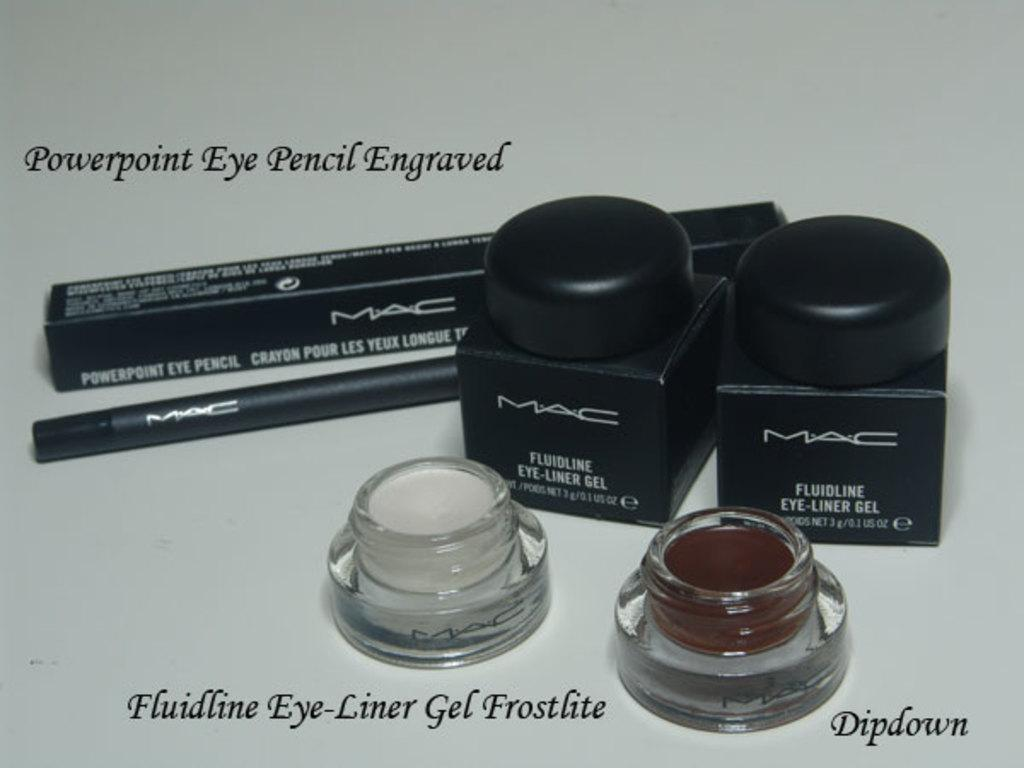Provide a one-sentence caption for the provided image. Various make up products on a table like Eye-liner and Dipdown. 